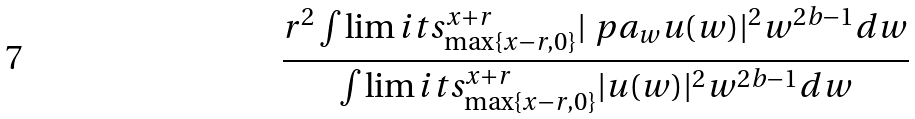Convert formula to latex. <formula><loc_0><loc_0><loc_500><loc_500>\frac { r ^ { 2 } \int \lim i t s _ { \max \{ x - r , 0 \} } ^ { x + r } | \ p a _ { w } u ( w ) | ^ { 2 } w ^ { 2 b - 1 } d w } { \int \lim i t s _ { \max \{ x - r , 0 \} } ^ { x + r } | u ( w ) | ^ { 2 } w ^ { 2 b - 1 } d w }</formula> 